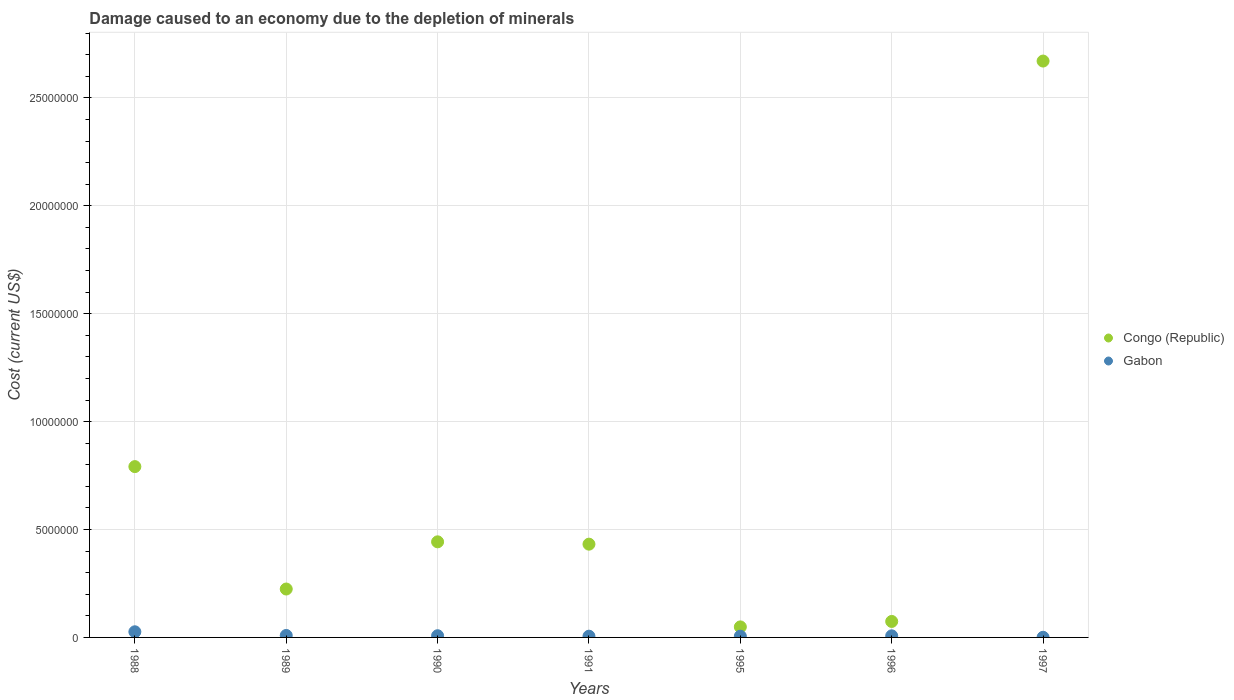Is the number of dotlines equal to the number of legend labels?
Keep it short and to the point. Yes. What is the cost of damage caused due to the depletion of minerals in Congo (Republic) in 1988?
Your answer should be compact. 7.92e+06. Across all years, what is the maximum cost of damage caused due to the depletion of minerals in Gabon?
Provide a succinct answer. 2.61e+05. Across all years, what is the minimum cost of damage caused due to the depletion of minerals in Gabon?
Your answer should be very brief. 6551.62. What is the total cost of damage caused due to the depletion of minerals in Gabon in the graph?
Provide a short and direct response. 6.26e+05. What is the difference between the cost of damage caused due to the depletion of minerals in Congo (Republic) in 1991 and that in 1997?
Your answer should be compact. -2.24e+07. What is the difference between the cost of damage caused due to the depletion of minerals in Congo (Republic) in 1990 and the cost of damage caused due to the depletion of minerals in Gabon in 1996?
Provide a succinct answer. 4.36e+06. What is the average cost of damage caused due to the depletion of minerals in Congo (Republic) per year?
Provide a succinct answer. 6.69e+06. In the year 1995, what is the difference between the cost of damage caused due to the depletion of minerals in Gabon and cost of damage caused due to the depletion of minerals in Congo (Republic)?
Ensure brevity in your answer.  -4.31e+05. In how many years, is the cost of damage caused due to the depletion of minerals in Gabon greater than 16000000 US$?
Give a very brief answer. 0. What is the ratio of the cost of damage caused due to the depletion of minerals in Congo (Republic) in 1989 to that in 1990?
Your response must be concise. 0.51. Is the cost of damage caused due to the depletion of minerals in Congo (Republic) in 1990 less than that in 1995?
Give a very brief answer. No. Is the difference between the cost of damage caused due to the depletion of minerals in Gabon in 1990 and 1991 greater than the difference between the cost of damage caused due to the depletion of minerals in Congo (Republic) in 1990 and 1991?
Your answer should be compact. No. What is the difference between the highest and the second highest cost of damage caused due to the depletion of minerals in Gabon?
Offer a very short reply. 1.71e+05. What is the difference between the highest and the lowest cost of damage caused due to the depletion of minerals in Congo (Republic)?
Offer a very short reply. 2.62e+07. Is the sum of the cost of damage caused due to the depletion of minerals in Congo (Republic) in 1988 and 1989 greater than the maximum cost of damage caused due to the depletion of minerals in Gabon across all years?
Your response must be concise. Yes. How many dotlines are there?
Give a very brief answer. 2. How many years are there in the graph?
Give a very brief answer. 7. Does the graph contain any zero values?
Offer a terse response. No. How are the legend labels stacked?
Offer a terse response. Vertical. What is the title of the graph?
Provide a short and direct response. Damage caused to an economy due to the depletion of minerals. What is the label or title of the X-axis?
Keep it short and to the point. Years. What is the label or title of the Y-axis?
Your answer should be compact. Cost (current US$). What is the Cost (current US$) in Congo (Republic) in 1988?
Offer a very short reply. 7.92e+06. What is the Cost (current US$) of Gabon in 1988?
Provide a succinct answer. 2.61e+05. What is the Cost (current US$) of Congo (Republic) in 1989?
Offer a very short reply. 2.24e+06. What is the Cost (current US$) in Gabon in 1989?
Provide a short and direct response. 9.08e+04. What is the Cost (current US$) of Congo (Republic) in 1990?
Ensure brevity in your answer.  4.43e+06. What is the Cost (current US$) in Gabon in 1990?
Offer a very short reply. 7.88e+04. What is the Cost (current US$) in Congo (Republic) in 1991?
Your response must be concise. 4.32e+06. What is the Cost (current US$) of Gabon in 1991?
Make the answer very short. 5.76e+04. What is the Cost (current US$) of Congo (Republic) in 1995?
Make the answer very short. 4.88e+05. What is the Cost (current US$) of Gabon in 1995?
Give a very brief answer. 5.69e+04. What is the Cost (current US$) in Congo (Republic) in 1996?
Make the answer very short. 7.40e+05. What is the Cost (current US$) of Gabon in 1996?
Offer a very short reply. 7.40e+04. What is the Cost (current US$) of Congo (Republic) in 1997?
Provide a succinct answer. 2.67e+07. What is the Cost (current US$) in Gabon in 1997?
Offer a terse response. 6551.62. Across all years, what is the maximum Cost (current US$) of Congo (Republic)?
Ensure brevity in your answer.  2.67e+07. Across all years, what is the maximum Cost (current US$) in Gabon?
Provide a short and direct response. 2.61e+05. Across all years, what is the minimum Cost (current US$) of Congo (Republic)?
Offer a terse response. 4.88e+05. Across all years, what is the minimum Cost (current US$) in Gabon?
Offer a terse response. 6551.62. What is the total Cost (current US$) in Congo (Republic) in the graph?
Your answer should be compact. 4.68e+07. What is the total Cost (current US$) of Gabon in the graph?
Your answer should be compact. 6.26e+05. What is the difference between the Cost (current US$) of Congo (Republic) in 1988 and that in 1989?
Offer a very short reply. 5.67e+06. What is the difference between the Cost (current US$) of Gabon in 1988 and that in 1989?
Ensure brevity in your answer.  1.71e+05. What is the difference between the Cost (current US$) in Congo (Republic) in 1988 and that in 1990?
Your answer should be compact. 3.49e+06. What is the difference between the Cost (current US$) of Gabon in 1988 and that in 1990?
Your answer should be very brief. 1.83e+05. What is the difference between the Cost (current US$) in Congo (Republic) in 1988 and that in 1991?
Make the answer very short. 3.59e+06. What is the difference between the Cost (current US$) of Gabon in 1988 and that in 1991?
Offer a very short reply. 2.04e+05. What is the difference between the Cost (current US$) of Congo (Republic) in 1988 and that in 1995?
Offer a very short reply. 7.43e+06. What is the difference between the Cost (current US$) in Gabon in 1988 and that in 1995?
Keep it short and to the point. 2.04e+05. What is the difference between the Cost (current US$) in Congo (Republic) in 1988 and that in 1996?
Make the answer very short. 7.18e+06. What is the difference between the Cost (current US$) in Gabon in 1988 and that in 1996?
Ensure brevity in your answer.  1.87e+05. What is the difference between the Cost (current US$) in Congo (Republic) in 1988 and that in 1997?
Your answer should be very brief. -1.88e+07. What is the difference between the Cost (current US$) of Gabon in 1988 and that in 1997?
Offer a terse response. 2.55e+05. What is the difference between the Cost (current US$) in Congo (Republic) in 1989 and that in 1990?
Offer a terse response. -2.19e+06. What is the difference between the Cost (current US$) of Gabon in 1989 and that in 1990?
Keep it short and to the point. 1.21e+04. What is the difference between the Cost (current US$) in Congo (Republic) in 1989 and that in 1991?
Your answer should be compact. -2.08e+06. What is the difference between the Cost (current US$) of Gabon in 1989 and that in 1991?
Your response must be concise. 3.32e+04. What is the difference between the Cost (current US$) of Congo (Republic) in 1989 and that in 1995?
Make the answer very short. 1.76e+06. What is the difference between the Cost (current US$) of Gabon in 1989 and that in 1995?
Your response must be concise. 3.39e+04. What is the difference between the Cost (current US$) of Congo (Republic) in 1989 and that in 1996?
Your answer should be compact. 1.50e+06. What is the difference between the Cost (current US$) of Gabon in 1989 and that in 1996?
Your answer should be very brief. 1.68e+04. What is the difference between the Cost (current US$) in Congo (Republic) in 1989 and that in 1997?
Offer a very short reply. -2.45e+07. What is the difference between the Cost (current US$) in Gabon in 1989 and that in 1997?
Your response must be concise. 8.43e+04. What is the difference between the Cost (current US$) of Congo (Republic) in 1990 and that in 1991?
Your answer should be very brief. 1.08e+05. What is the difference between the Cost (current US$) of Gabon in 1990 and that in 1991?
Give a very brief answer. 2.11e+04. What is the difference between the Cost (current US$) in Congo (Republic) in 1990 and that in 1995?
Ensure brevity in your answer.  3.94e+06. What is the difference between the Cost (current US$) of Gabon in 1990 and that in 1995?
Keep it short and to the point. 2.18e+04. What is the difference between the Cost (current US$) of Congo (Republic) in 1990 and that in 1996?
Offer a very short reply. 3.69e+06. What is the difference between the Cost (current US$) in Gabon in 1990 and that in 1996?
Provide a succinct answer. 4723.27. What is the difference between the Cost (current US$) in Congo (Republic) in 1990 and that in 1997?
Your answer should be very brief. -2.23e+07. What is the difference between the Cost (current US$) in Gabon in 1990 and that in 1997?
Ensure brevity in your answer.  7.22e+04. What is the difference between the Cost (current US$) in Congo (Republic) in 1991 and that in 1995?
Make the answer very short. 3.83e+06. What is the difference between the Cost (current US$) in Gabon in 1991 and that in 1995?
Make the answer very short. 681.29. What is the difference between the Cost (current US$) of Congo (Republic) in 1991 and that in 1996?
Your answer should be very brief. 3.58e+06. What is the difference between the Cost (current US$) in Gabon in 1991 and that in 1996?
Keep it short and to the point. -1.64e+04. What is the difference between the Cost (current US$) in Congo (Republic) in 1991 and that in 1997?
Offer a very short reply. -2.24e+07. What is the difference between the Cost (current US$) of Gabon in 1991 and that in 1997?
Your response must be concise. 5.11e+04. What is the difference between the Cost (current US$) in Congo (Republic) in 1995 and that in 1996?
Provide a succinct answer. -2.52e+05. What is the difference between the Cost (current US$) of Gabon in 1995 and that in 1996?
Provide a short and direct response. -1.71e+04. What is the difference between the Cost (current US$) in Congo (Republic) in 1995 and that in 1997?
Your response must be concise. -2.62e+07. What is the difference between the Cost (current US$) in Gabon in 1995 and that in 1997?
Your answer should be compact. 5.04e+04. What is the difference between the Cost (current US$) of Congo (Republic) in 1996 and that in 1997?
Offer a very short reply. -2.60e+07. What is the difference between the Cost (current US$) of Gabon in 1996 and that in 1997?
Ensure brevity in your answer.  6.75e+04. What is the difference between the Cost (current US$) of Congo (Republic) in 1988 and the Cost (current US$) of Gabon in 1989?
Keep it short and to the point. 7.82e+06. What is the difference between the Cost (current US$) of Congo (Republic) in 1988 and the Cost (current US$) of Gabon in 1990?
Ensure brevity in your answer.  7.84e+06. What is the difference between the Cost (current US$) of Congo (Republic) in 1988 and the Cost (current US$) of Gabon in 1991?
Offer a terse response. 7.86e+06. What is the difference between the Cost (current US$) of Congo (Republic) in 1988 and the Cost (current US$) of Gabon in 1995?
Your answer should be very brief. 7.86e+06. What is the difference between the Cost (current US$) of Congo (Republic) in 1988 and the Cost (current US$) of Gabon in 1996?
Make the answer very short. 7.84e+06. What is the difference between the Cost (current US$) in Congo (Republic) in 1988 and the Cost (current US$) in Gabon in 1997?
Offer a terse response. 7.91e+06. What is the difference between the Cost (current US$) of Congo (Republic) in 1989 and the Cost (current US$) of Gabon in 1990?
Ensure brevity in your answer.  2.16e+06. What is the difference between the Cost (current US$) in Congo (Republic) in 1989 and the Cost (current US$) in Gabon in 1991?
Keep it short and to the point. 2.19e+06. What is the difference between the Cost (current US$) in Congo (Republic) in 1989 and the Cost (current US$) in Gabon in 1995?
Make the answer very short. 2.19e+06. What is the difference between the Cost (current US$) in Congo (Republic) in 1989 and the Cost (current US$) in Gabon in 1996?
Provide a short and direct response. 2.17e+06. What is the difference between the Cost (current US$) of Congo (Republic) in 1989 and the Cost (current US$) of Gabon in 1997?
Ensure brevity in your answer.  2.24e+06. What is the difference between the Cost (current US$) in Congo (Republic) in 1990 and the Cost (current US$) in Gabon in 1991?
Make the answer very short. 4.37e+06. What is the difference between the Cost (current US$) of Congo (Republic) in 1990 and the Cost (current US$) of Gabon in 1995?
Offer a very short reply. 4.37e+06. What is the difference between the Cost (current US$) in Congo (Republic) in 1990 and the Cost (current US$) in Gabon in 1996?
Offer a very short reply. 4.36e+06. What is the difference between the Cost (current US$) in Congo (Republic) in 1990 and the Cost (current US$) in Gabon in 1997?
Provide a succinct answer. 4.42e+06. What is the difference between the Cost (current US$) of Congo (Republic) in 1991 and the Cost (current US$) of Gabon in 1995?
Offer a very short reply. 4.26e+06. What is the difference between the Cost (current US$) in Congo (Republic) in 1991 and the Cost (current US$) in Gabon in 1996?
Ensure brevity in your answer.  4.25e+06. What is the difference between the Cost (current US$) in Congo (Republic) in 1991 and the Cost (current US$) in Gabon in 1997?
Your answer should be compact. 4.32e+06. What is the difference between the Cost (current US$) of Congo (Republic) in 1995 and the Cost (current US$) of Gabon in 1996?
Provide a succinct answer. 4.14e+05. What is the difference between the Cost (current US$) in Congo (Republic) in 1995 and the Cost (current US$) in Gabon in 1997?
Give a very brief answer. 4.82e+05. What is the difference between the Cost (current US$) in Congo (Republic) in 1996 and the Cost (current US$) in Gabon in 1997?
Ensure brevity in your answer.  7.34e+05. What is the average Cost (current US$) of Congo (Republic) per year?
Your answer should be very brief. 6.69e+06. What is the average Cost (current US$) in Gabon per year?
Your answer should be compact. 8.95e+04. In the year 1988, what is the difference between the Cost (current US$) in Congo (Republic) and Cost (current US$) in Gabon?
Keep it short and to the point. 7.65e+06. In the year 1989, what is the difference between the Cost (current US$) of Congo (Republic) and Cost (current US$) of Gabon?
Give a very brief answer. 2.15e+06. In the year 1990, what is the difference between the Cost (current US$) in Congo (Republic) and Cost (current US$) in Gabon?
Your response must be concise. 4.35e+06. In the year 1991, what is the difference between the Cost (current US$) of Congo (Republic) and Cost (current US$) of Gabon?
Ensure brevity in your answer.  4.26e+06. In the year 1995, what is the difference between the Cost (current US$) of Congo (Republic) and Cost (current US$) of Gabon?
Your answer should be very brief. 4.31e+05. In the year 1996, what is the difference between the Cost (current US$) in Congo (Republic) and Cost (current US$) in Gabon?
Provide a succinct answer. 6.66e+05. In the year 1997, what is the difference between the Cost (current US$) in Congo (Republic) and Cost (current US$) in Gabon?
Make the answer very short. 2.67e+07. What is the ratio of the Cost (current US$) in Congo (Republic) in 1988 to that in 1989?
Your answer should be compact. 3.53. What is the ratio of the Cost (current US$) in Gabon in 1988 to that in 1989?
Your answer should be compact. 2.88. What is the ratio of the Cost (current US$) of Congo (Republic) in 1988 to that in 1990?
Keep it short and to the point. 1.79. What is the ratio of the Cost (current US$) of Gabon in 1988 to that in 1990?
Your answer should be compact. 3.32. What is the ratio of the Cost (current US$) of Congo (Republic) in 1988 to that in 1991?
Provide a succinct answer. 1.83. What is the ratio of the Cost (current US$) of Gabon in 1988 to that in 1991?
Keep it short and to the point. 4.54. What is the ratio of the Cost (current US$) in Congo (Republic) in 1988 to that in 1995?
Your response must be concise. 16.22. What is the ratio of the Cost (current US$) in Gabon in 1988 to that in 1995?
Your answer should be very brief. 4.59. What is the ratio of the Cost (current US$) of Congo (Republic) in 1988 to that in 1996?
Ensure brevity in your answer.  10.69. What is the ratio of the Cost (current US$) in Gabon in 1988 to that in 1996?
Ensure brevity in your answer.  3.53. What is the ratio of the Cost (current US$) in Congo (Republic) in 1988 to that in 1997?
Your answer should be compact. 0.3. What is the ratio of the Cost (current US$) of Gabon in 1988 to that in 1997?
Ensure brevity in your answer.  39.9. What is the ratio of the Cost (current US$) of Congo (Republic) in 1989 to that in 1990?
Your response must be concise. 0.51. What is the ratio of the Cost (current US$) of Gabon in 1989 to that in 1990?
Give a very brief answer. 1.15. What is the ratio of the Cost (current US$) in Congo (Republic) in 1989 to that in 1991?
Your response must be concise. 0.52. What is the ratio of the Cost (current US$) of Gabon in 1989 to that in 1991?
Offer a very short reply. 1.58. What is the ratio of the Cost (current US$) in Congo (Republic) in 1989 to that in 1995?
Make the answer very short. 4.6. What is the ratio of the Cost (current US$) of Gabon in 1989 to that in 1995?
Your answer should be very brief. 1.6. What is the ratio of the Cost (current US$) of Congo (Republic) in 1989 to that in 1996?
Provide a succinct answer. 3.03. What is the ratio of the Cost (current US$) of Gabon in 1989 to that in 1996?
Offer a very short reply. 1.23. What is the ratio of the Cost (current US$) of Congo (Republic) in 1989 to that in 1997?
Keep it short and to the point. 0.08. What is the ratio of the Cost (current US$) of Gabon in 1989 to that in 1997?
Provide a succinct answer. 13.87. What is the ratio of the Cost (current US$) in Congo (Republic) in 1990 to that in 1991?
Give a very brief answer. 1.03. What is the ratio of the Cost (current US$) in Gabon in 1990 to that in 1991?
Your answer should be very brief. 1.37. What is the ratio of the Cost (current US$) in Congo (Republic) in 1990 to that in 1995?
Offer a terse response. 9.08. What is the ratio of the Cost (current US$) of Gabon in 1990 to that in 1995?
Your response must be concise. 1.38. What is the ratio of the Cost (current US$) of Congo (Republic) in 1990 to that in 1996?
Your answer should be compact. 5.98. What is the ratio of the Cost (current US$) in Gabon in 1990 to that in 1996?
Your answer should be very brief. 1.06. What is the ratio of the Cost (current US$) of Congo (Republic) in 1990 to that in 1997?
Ensure brevity in your answer.  0.17. What is the ratio of the Cost (current US$) of Gabon in 1990 to that in 1997?
Provide a succinct answer. 12.02. What is the ratio of the Cost (current US$) of Congo (Republic) in 1991 to that in 1995?
Your answer should be compact. 8.85. What is the ratio of the Cost (current US$) of Gabon in 1991 to that in 1995?
Keep it short and to the point. 1.01. What is the ratio of the Cost (current US$) of Congo (Republic) in 1991 to that in 1996?
Offer a very short reply. 5.84. What is the ratio of the Cost (current US$) of Gabon in 1991 to that in 1996?
Make the answer very short. 0.78. What is the ratio of the Cost (current US$) of Congo (Republic) in 1991 to that in 1997?
Make the answer very short. 0.16. What is the ratio of the Cost (current US$) of Gabon in 1991 to that in 1997?
Offer a terse response. 8.8. What is the ratio of the Cost (current US$) in Congo (Republic) in 1995 to that in 1996?
Offer a very short reply. 0.66. What is the ratio of the Cost (current US$) of Gabon in 1995 to that in 1996?
Your answer should be compact. 0.77. What is the ratio of the Cost (current US$) of Congo (Republic) in 1995 to that in 1997?
Give a very brief answer. 0.02. What is the ratio of the Cost (current US$) of Gabon in 1995 to that in 1997?
Offer a terse response. 8.69. What is the ratio of the Cost (current US$) of Congo (Republic) in 1996 to that in 1997?
Give a very brief answer. 0.03. What is the ratio of the Cost (current US$) of Gabon in 1996 to that in 1997?
Keep it short and to the point. 11.3. What is the difference between the highest and the second highest Cost (current US$) in Congo (Republic)?
Make the answer very short. 1.88e+07. What is the difference between the highest and the second highest Cost (current US$) in Gabon?
Make the answer very short. 1.71e+05. What is the difference between the highest and the lowest Cost (current US$) of Congo (Republic)?
Ensure brevity in your answer.  2.62e+07. What is the difference between the highest and the lowest Cost (current US$) of Gabon?
Keep it short and to the point. 2.55e+05. 